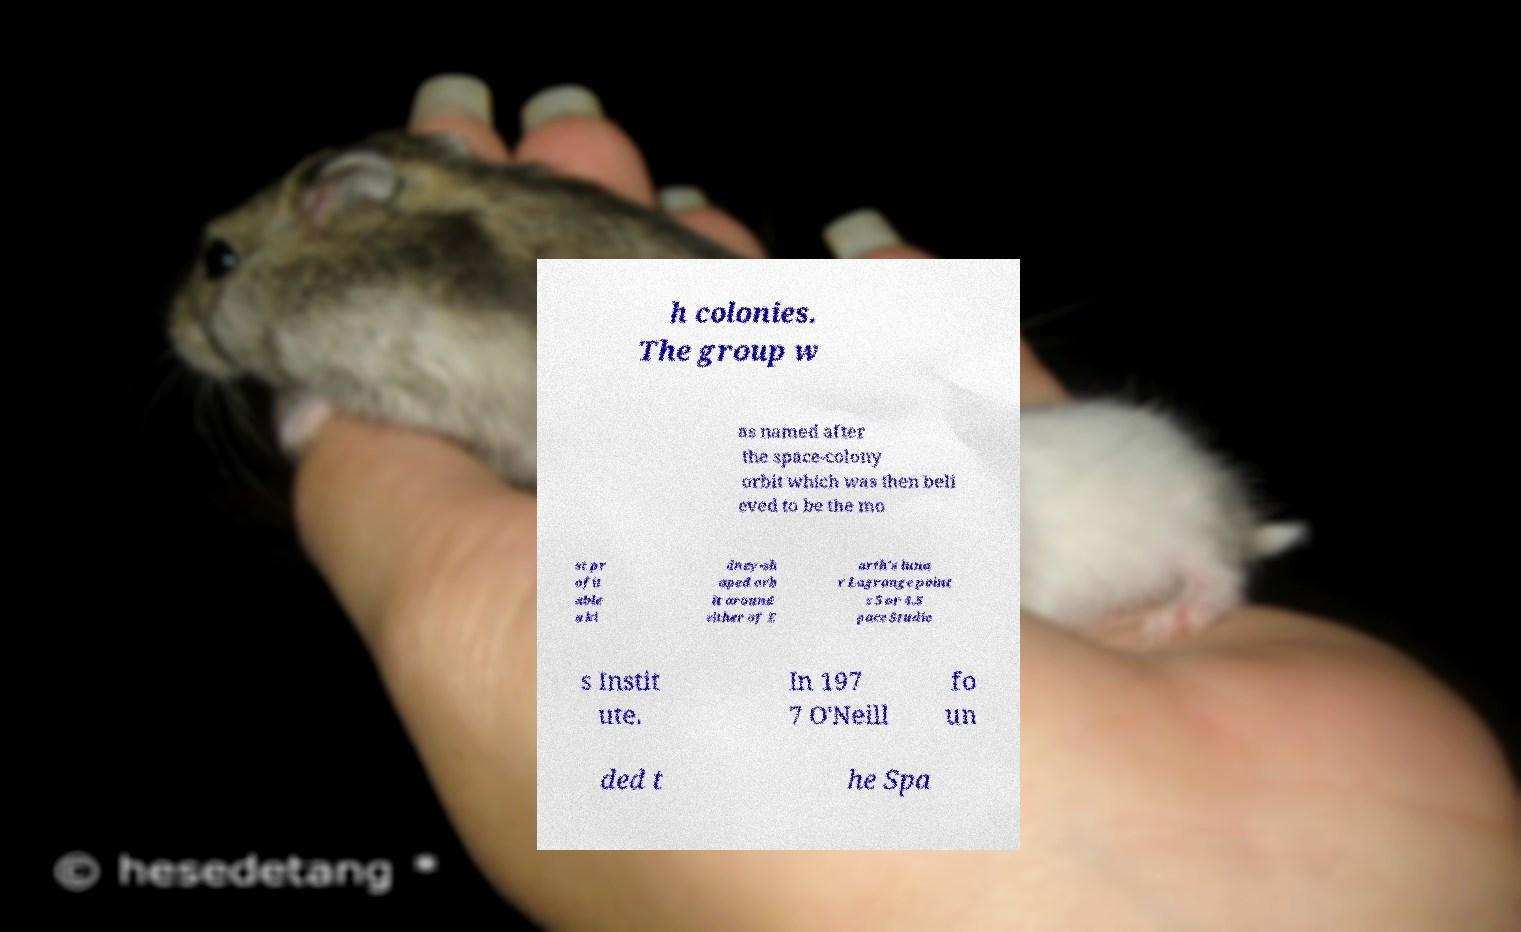Can you read and provide the text displayed in the image?This photo seems to have some interesting text. Can you extract and type it out for me? h colonies. The group w as named after the space-colony orbit which was then beli eved to be the mo st pr ofit able a ki dney-sh aped orb it around either of E arth's luna r Lagrange point s 5 or 4.S pace Studie s Instit ute. In 197 7 O'Neill fo un ded t he Spa 